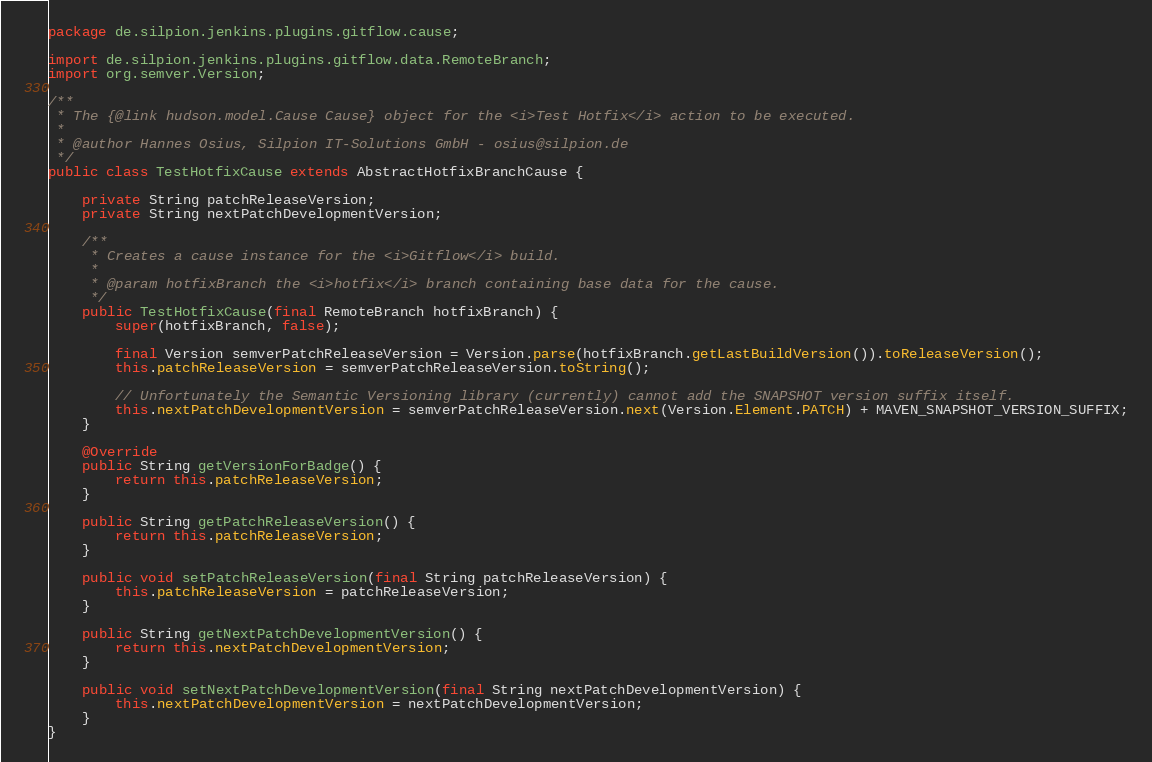Convert code to text. <code><loc_0><loc_0><loc_500><loc_500><_Java_>package de.silpion.jenkins.plugins.gitflow.cause;

import de.silpion.jenkins.plugins.gitflow.data.RemoteBranch;
import org.semver.Version;

/**
 * The {@link hudson.model.Cause Cause} object for the <i>Test Hotfix</i> action to be executed.
 *
 * @author Hannes Osius, Silpion IT-Solutions GmbH - osius@silpion.de
 */
public class TestHotfixCause extends AbstractHotfixBranchCause {

    private String patchReleaseVersion;
    private String nextPatchDevelopmentVersion;

    /**
     * Creates a cause instance for the <i>Gitflow</i> build.
     *
     * @param hotfixBranch the <i>hotfix</i> branch containing base data for the cause.
     */
    public TestHotfixCause(final RemoteBranch hotfixBranch) {
        super(hotfixBranch, false);

        final Version semverPatchReleaseVersion = Version.parse(hotfixBranch.getLastBuildVersion()).toReleaseVersion();
        this.patchReleaseVersion = semverPatchReleaseVersion.toString();

        // Unfortunately the Semantic Versioning library (currently) cannot add the SNAPSHOT version suffix itself.
        this.nextPatchDevelopmentVersion = semverPatchReleaseVersion.next(Version.Element.PATCH) + MAVEN_SNAPSHOT_VERSION_SUFFIX;
    }

    @Override
    public String getVersionForBadge() {
        return this.patchReleaseVersion;
    }

    public String getPatchReleaseVersion() {
        return this.patchReleaseVersion;
    }

    public void setPatchReleaseVersion(final String patchReleaseVersion) {
        this.patchReleaseVersion = patchReleaseVersion;
    }

    public String getNextPatchDevelopmentVersion() {
        return this.nextPatchDevelopmentVersion;
    }

    public void setNextPatchDevelopmentVersion(final String nextPatchDevelopmentVersion) {
        this.nextPatchDevelopmentVersion = nextPatchDevelopmentVersion;
    }
}
</code> 